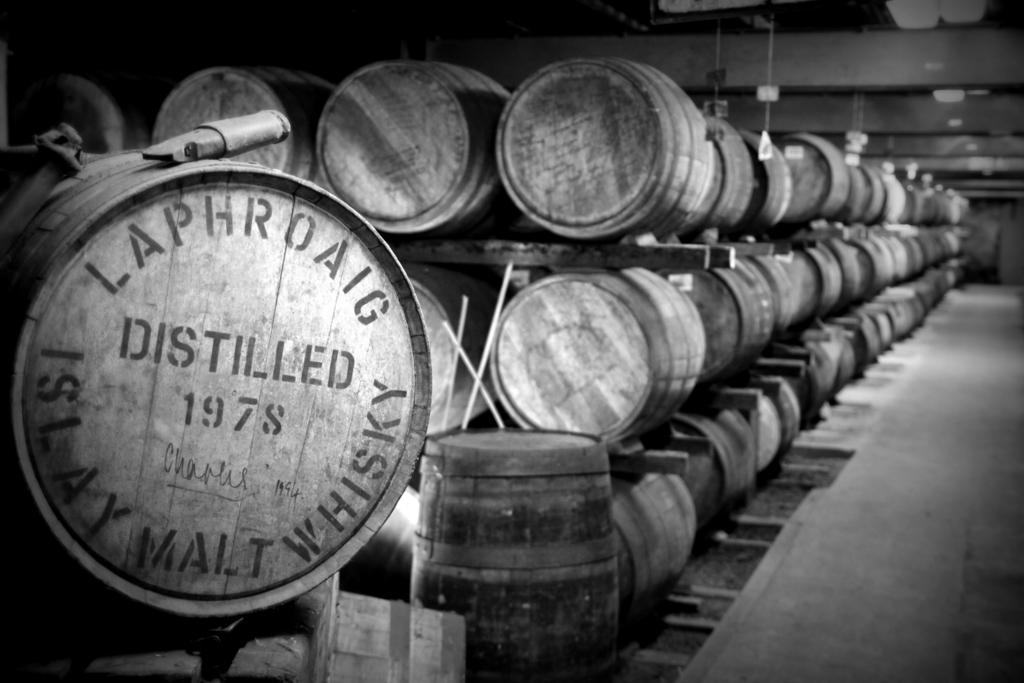What is the color scheme of the image? The image is black and white. What objects can be seen in the image? There are barrels in the image. How are the barrels arranged? The barrels are on racks. Is there any text or markings on the barrels? Yes, there is writing on the barrels. What type of cake is being served on a bike in the image? There is no cake or bike present in the image; it features black and white barrels with writing on them. 